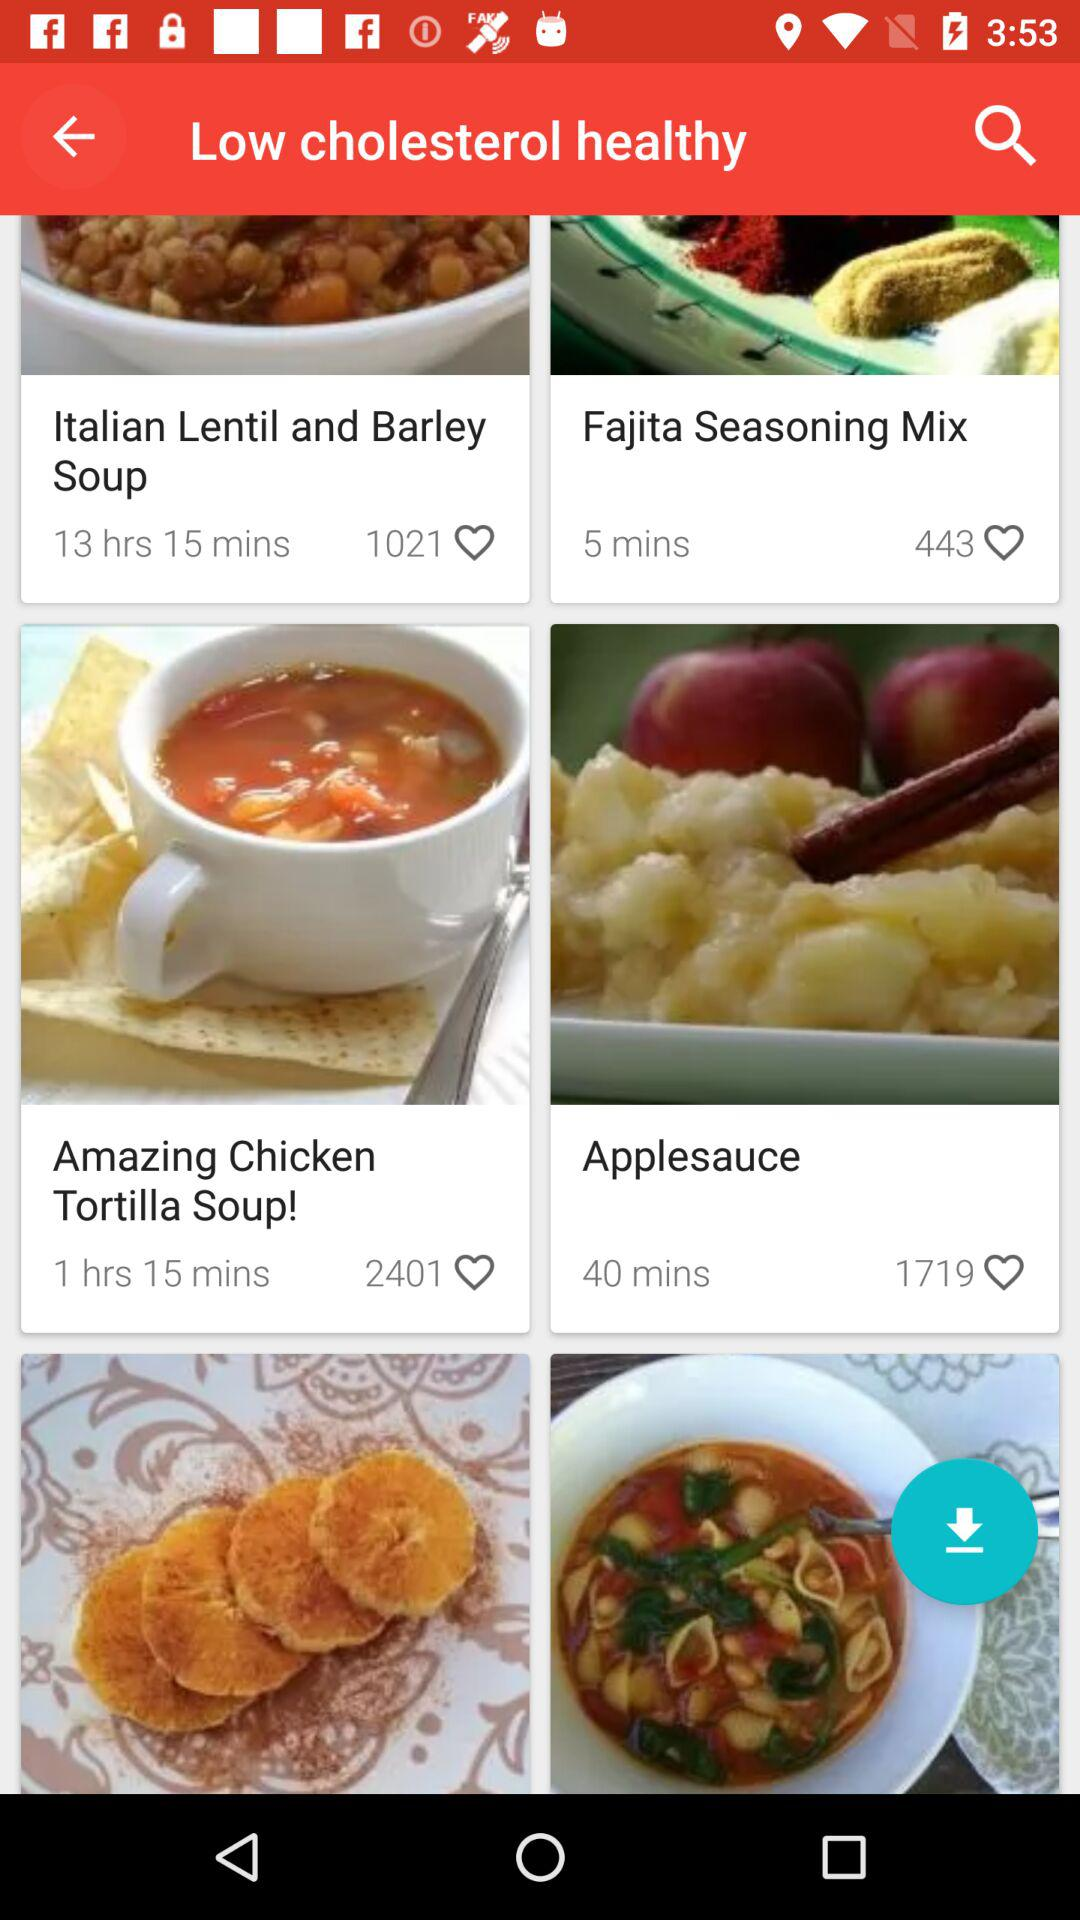How many recipes have a cooking time of less than an hour?
Answer the question using a single word or phrase. 2 